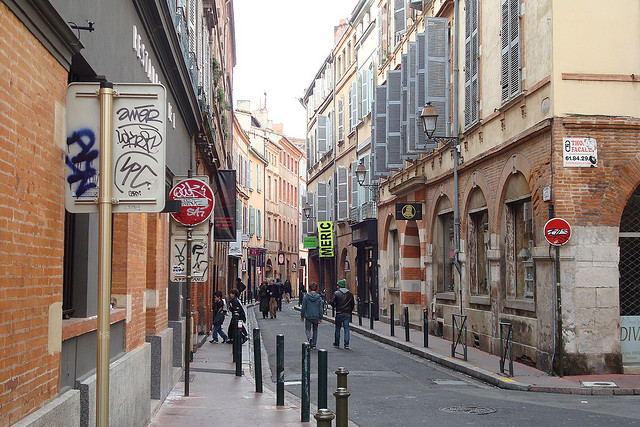Identify and read out the text in this image. FACAL MERIC DIV PTN VP SAi amer 